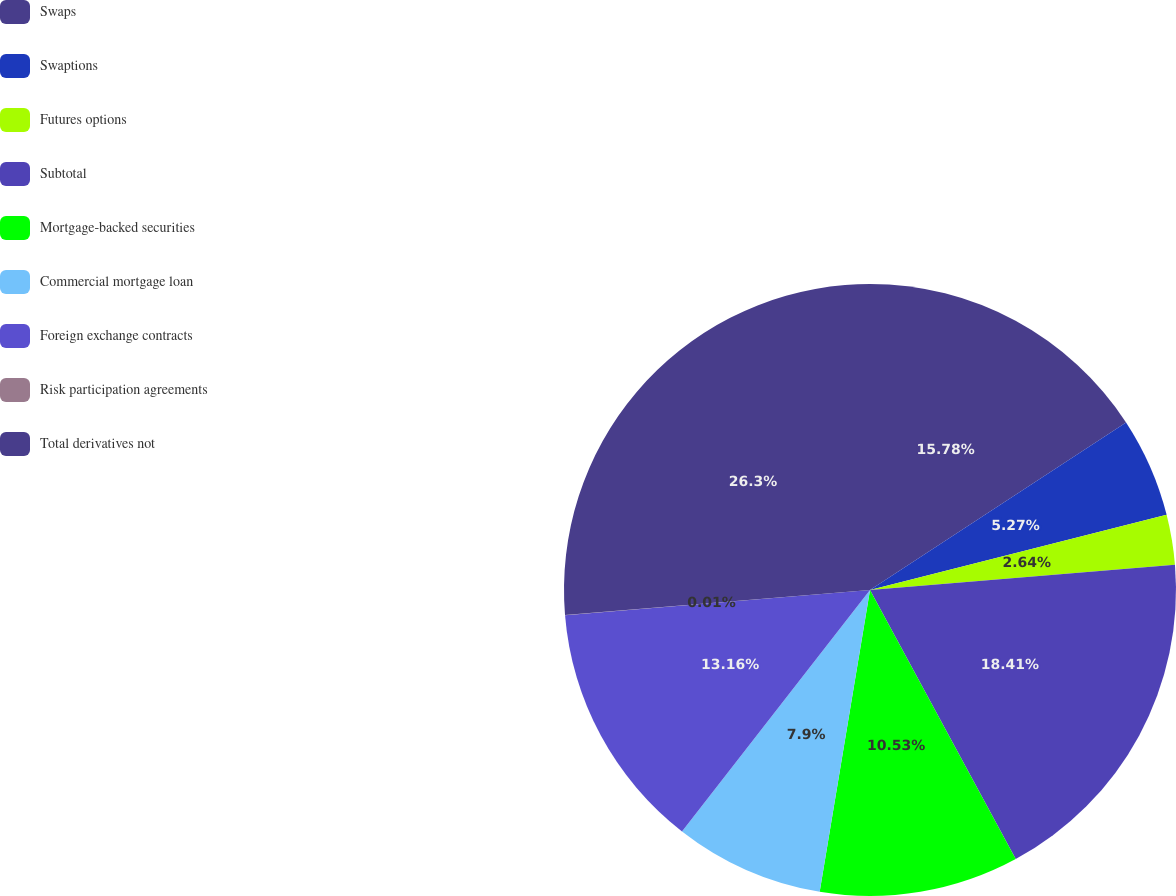Convert chart. <chart><loc_0><loc_0><loc_500><loc_500><pie_chart><fcel>Swaps<fcel>Swaptions<fcel>Futures options<fcel>Subtotal<fcel>Mortgage-backed securities<fcel>Commercial mortgage loan<fcel>Foreign exchange contracts<fcel>Risk participation agreements<fcel>Total derivatives not<nl><fcel>15.78%<fcel>5.27%<fcel>2.64%<fcel>18.41%<fcel>10.53%<fcel>7.9%<fcel>13.16%<fcel>0.01%<fcel>26.3%<nl></chart> 